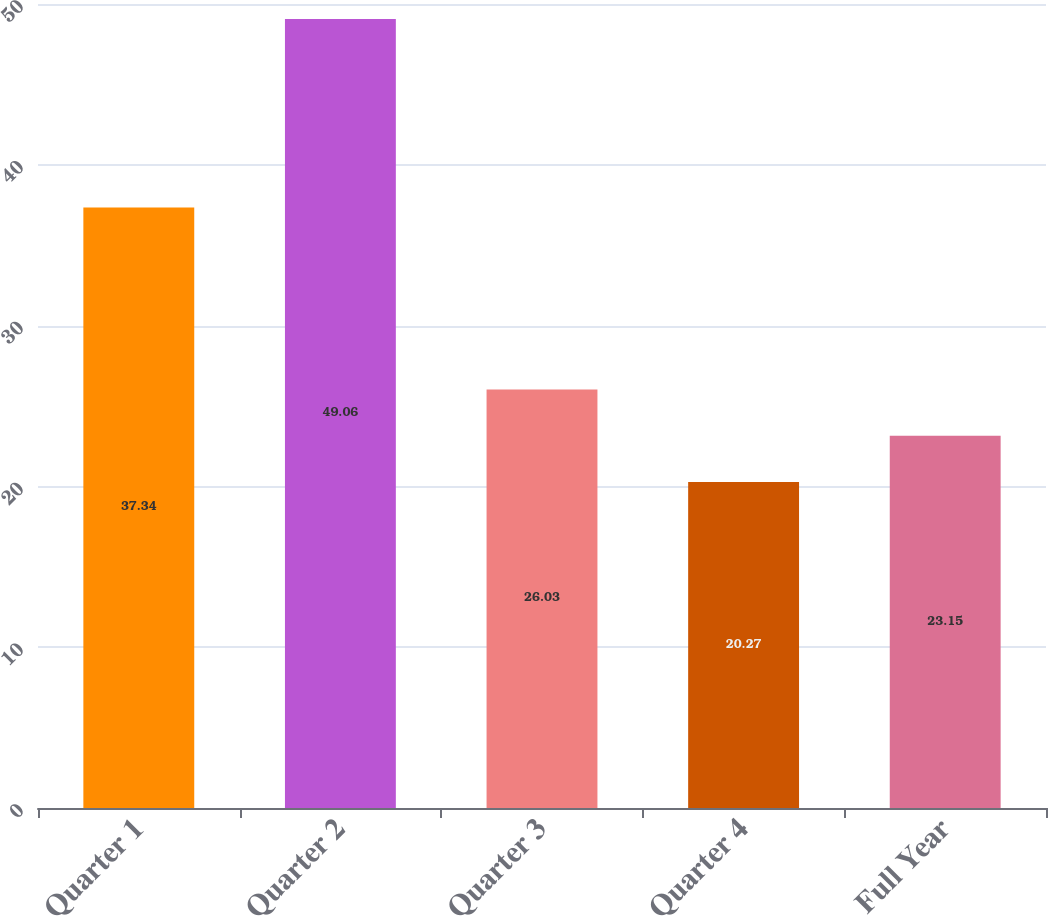<chart> <loc_0><loc_0><loc_500><loc_500><bar_chart><fcel>Quarter 1<fcel>Quarter 2<fcel>Quarter 3<fcel>Quarter 4<fcel>Full Year<nl><fcel>37.34<fcel>49.06<fcel>26.03<fcel>20.27<fcel>23.15<nl></chart> 